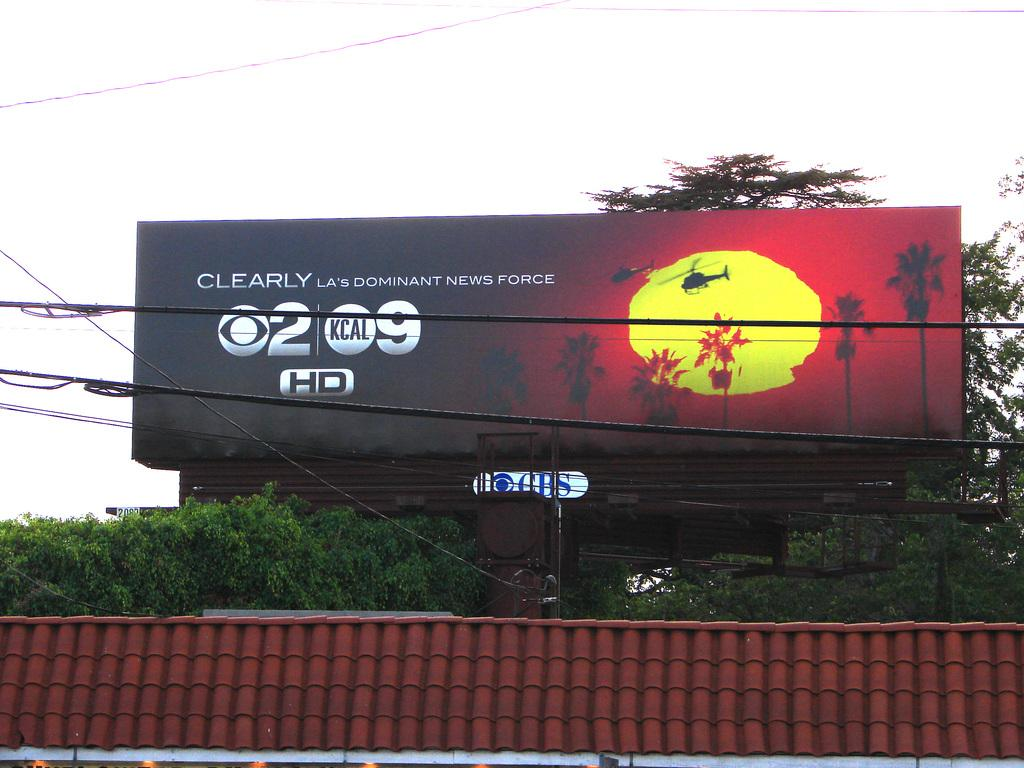<image>
Create a compact narrative representing the image presented. A CBS billboard stating they are clearly LA's dominant news force. 